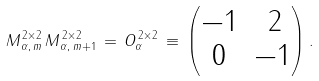<formula> <loc_0><loc_0><loc_500><loc_500>M ^ { \, 2 \times 2 } _ { \, \alpha , \, m } \, M ^ { \, 2 \times 2 } _ { \, \alpha , \, m + 1 } \, = \, O _ { \alpha } ^ { \, 2 \times 2 } \, \equiv \, \begin{pmatrix} - 1 & \, 2 \\ 0 & - 1 \end{pmatrix} .</formula> 